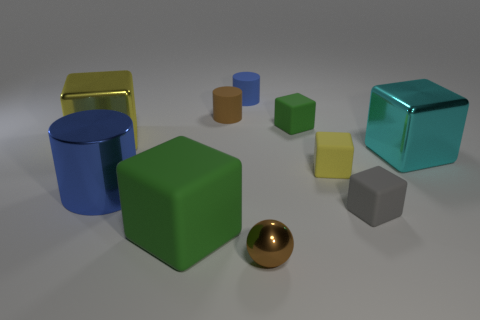Subtract all gray cubes. How many cubes are left? 5 Subtract all tiny yellow cubes. How many cubes are left? 5 Subtract 4 blocks. How many blocks are left? 2 Subtract all purple blocks. Subtract all blue spheres. How many blocks are left? 6 Subtract all cylinders. How many objects are left? 7 Subtract all big gray metallic cubes. Subtract all tiny gray objects. How many objects are left? 9 Add 8 yellow metallic objects. How many yellow metallic objects are left? 9 Add 6 small cylinders. How many small cylinders exist? 8 Subtract 0 gray cylinders. How many objects are left? 10 